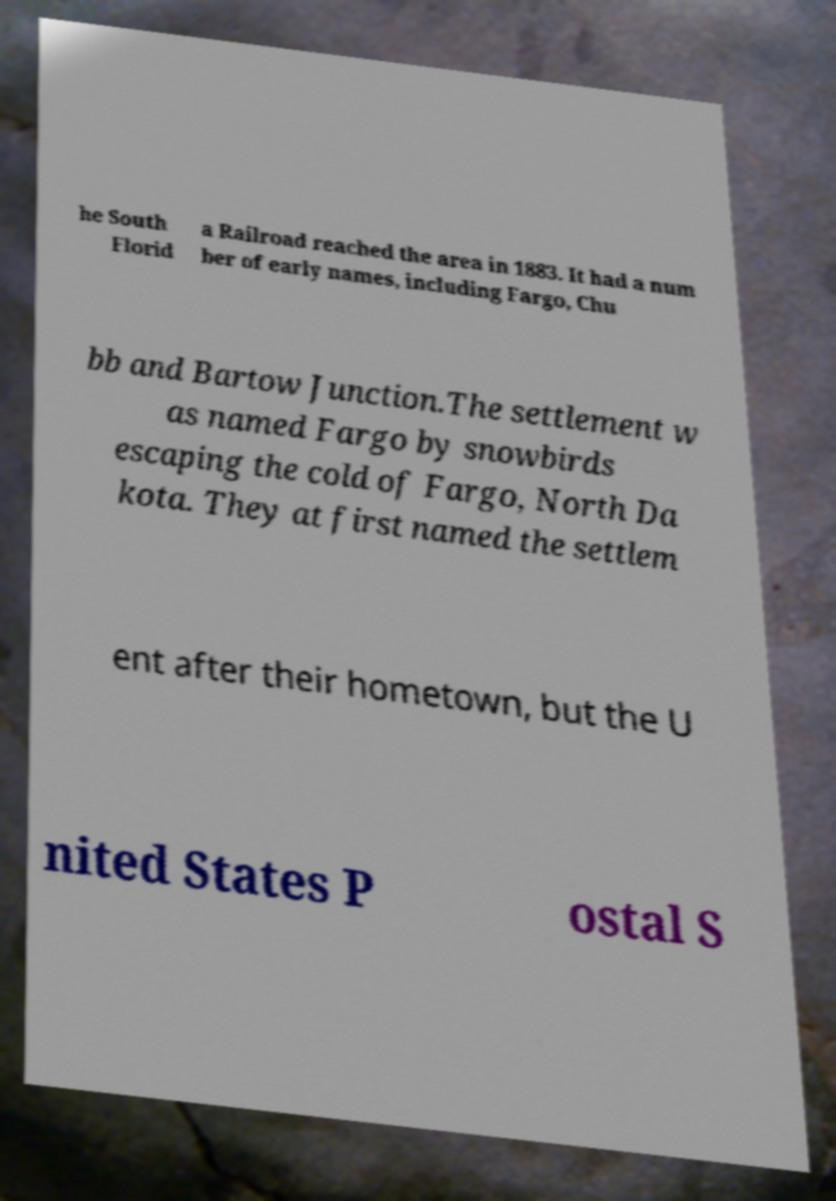What messages or text are displayed in this image? I need them in a readable, typed format. he South Florid a Railroad reached the area in 1883. It had a num ber of early names, including Fargo, Chu bb and Bartow Junction.The settlement w as named Fargo by snowbirds escaping the cold of Fargo, North Da kota. They at first named the settlem ent after their hometown, but the U nited States P ostal S 